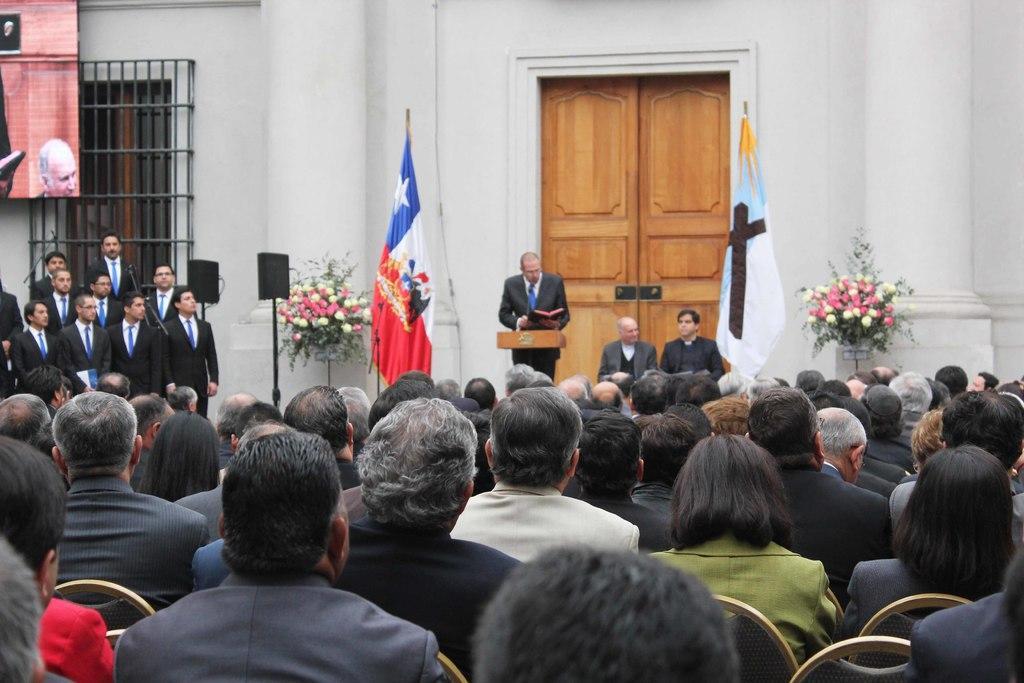How would you summarize this image in a sentence or two? In this image, there are a few people. Among them, we can see a person holding an object. We can see some flowers, pole stands. We can also see the wall with doors and a metal object. We can also see the screen on the top left corner. We can also see some flags. 